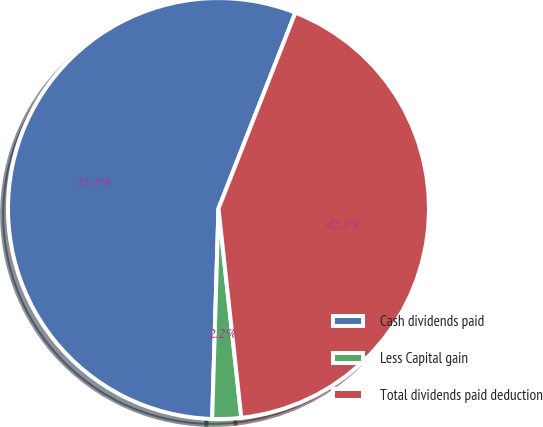Convert chart. <chart><loc_0><loc_0><loc_500><loc_500><pie_chart><fcel>Cash dividends paid<fcel>Less Capital gain<fcel>Total dividends paid deduction<nl><fcel>55.47%<fcel>2.21%<fcel>42.31%<nl></chart> 